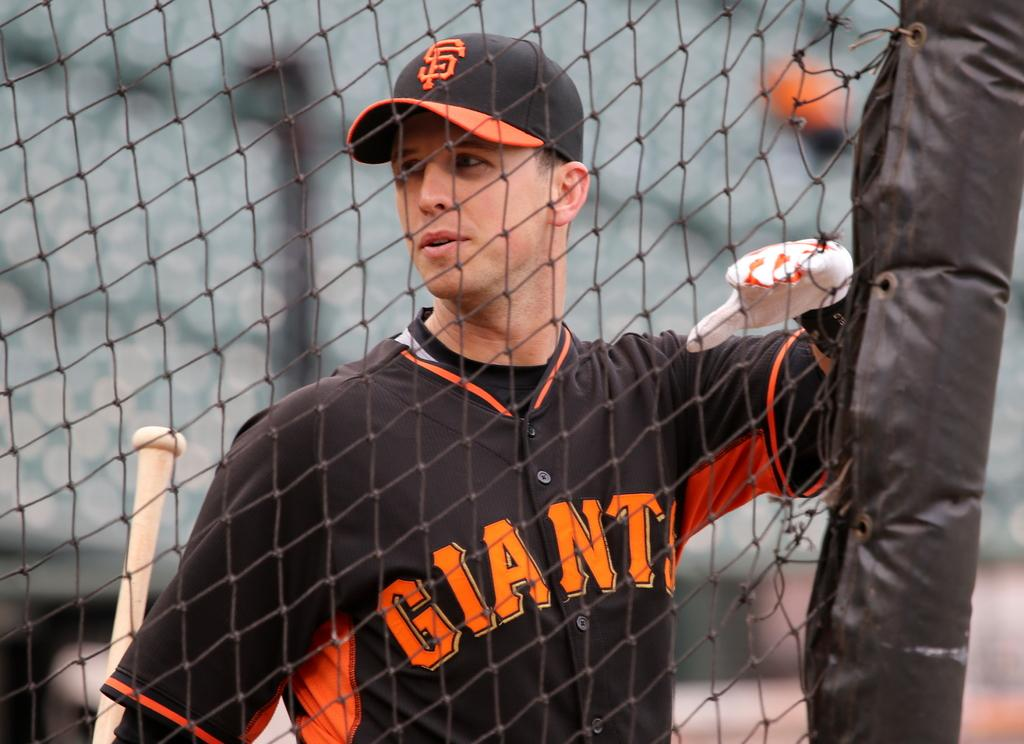<image>
Write a terse but informative summary of the picture. San Fransisco Giants baseball player holding a baseball bat and watching a game. 